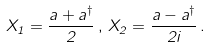<formula> <loc_0><loc_0><loc_500><loc_500>X _ { 1 } = \frac { a + a ^ { \dagger } } { 2 } \, , \, X _ { 2 } = \frac { a - a ^ { \dagger } } { 2 i } \, .</formula> 